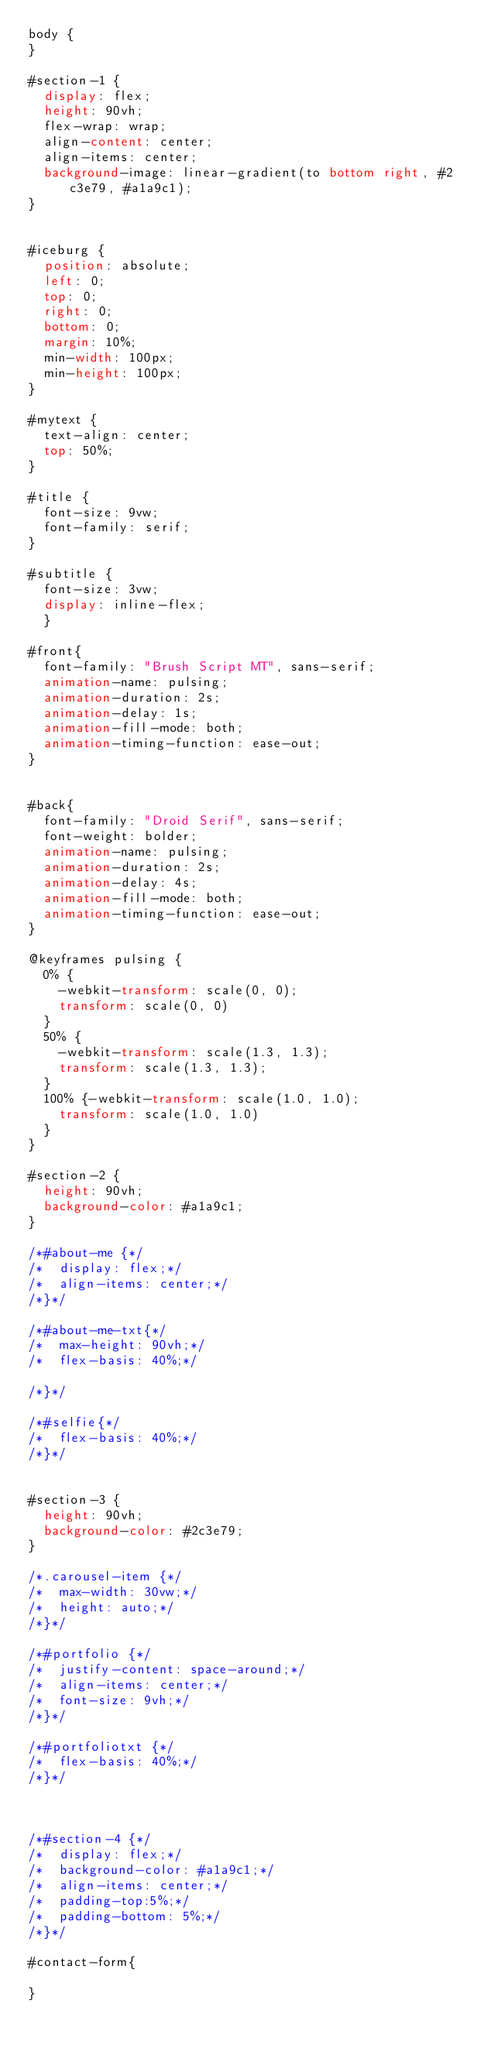<code> <loc_0><loc_0><loc_500><loc_500><_CSS_>body {
}

#section-1 {
	display: flex;
	height: 90vh;
	flex-wrap: wrap;
	align-content: center;
	align-items: center;
	background-image: linear-gradient(to bottom right, #2c3e79, #a1a9c1);
}


#iceburg {
	position: absolute;
	left: 0;
	top: 0;
	right: 0;
	bottom: 0;
	margin: 10%;
	min-width: 100px;
	min-height: 100px;
}

#mytext {
	text-align: center;
	top: 50%;
}

#title {
	font-size: 9vw;
	font-family: serif;
}

#subtitle {
	font-size: 3vw;
	display: inline-flex;
	}

#front{
	font-family: "Brush Script MT", sans-serif;
	animation-name: pulsing;
	animation-duration: 2s;
	animation-delay: 1s;
	animation-fill-mode: both;
	animation-timing-function: ease-out;
}


#back{
	font-family: "Droid Serif", sans-serif;
	font-weight: bolder;
	animation-name: pulsing;
	animation-duration: 2s;
	animation-delay: 4s;
	animation-fill-mode: both;
	animation-timing-function: ease-out;
}

@keyframes pulsing {
	0% {
		-webkit-transform: scale(0, 0);
		transform: scale(0, 0)
	}
	50% {
		-webkit-transform: scale(1.3, 1.3);
		transform: scale(1.3, 1.3);
	}
	100% {-webkit-transform: scale(1.0, 1.0);
		transform: scale(1.0, 1.0)
	}
}

#section-2 {
	height: 90vh;
	background-color: #a1a9c1;
}

/*#about-me {*/
/*	display: flex;*/
/*	align-items: center;*/
/*}*/

/*#about-me-txt{*/
/*	max-height: 90vh;*/
/*	flex-basis: 40%;*/

/*}*/

/*#selfie{*/
/*	flex-basis: 40%;*/
/*}*/


#section-3 {
	height: 90vh;
	background-color: #2c3e79;
}

/*.carousel-item {*/
/*	max-width: 30vw;*/
/*	height: auto;*/
/*}*/

/*#portfolio {*/
/*	justify-content: space-around;*/
/*	align-items: center;*/
/*	font-size: 9vh;*/
/*}*/

/*#portfoliotxt {*/
/*	flex-basis: 40%;*/
/*}*/



/*#section-4 {*/
/*	display: flex;*/
/*	background-color: #a1a9c1;*/
/*	align-items: center;*/
/*	padding-top:5%;*/
/*	padding-bottom: 5%;*/
/*}*/

#contact-form{

}








</code> 